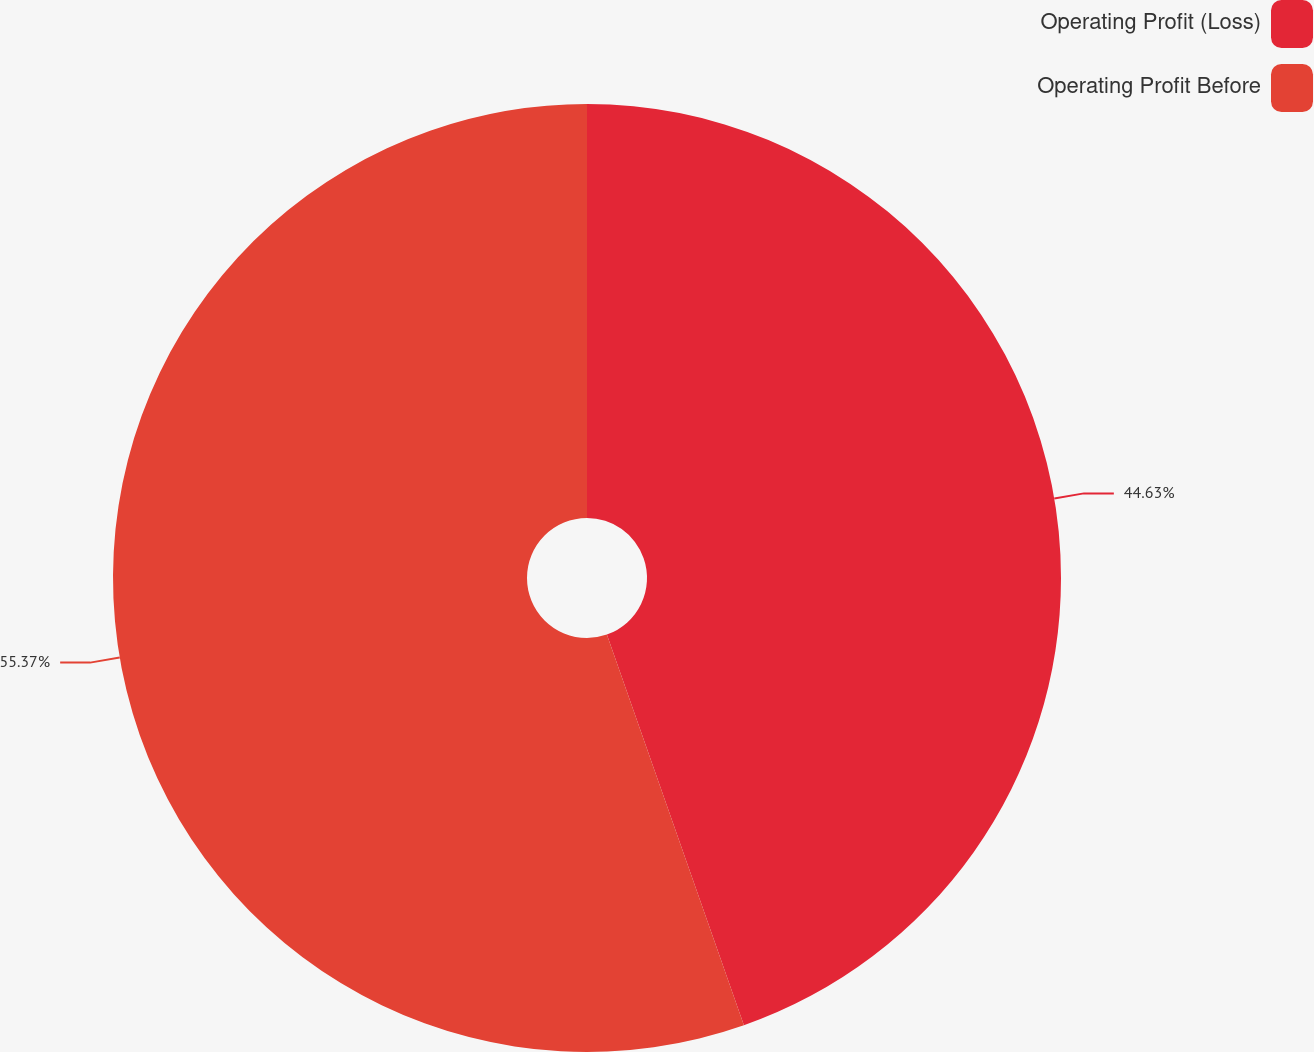<chart> <loc_0><loc_0><loc_500><loc_500><pie_chart><fcel>Operating Profit (Loss)<fcel>Operating Profit Before<nl><fcel>44.63%<fcel>55.37%<nl></chart> 